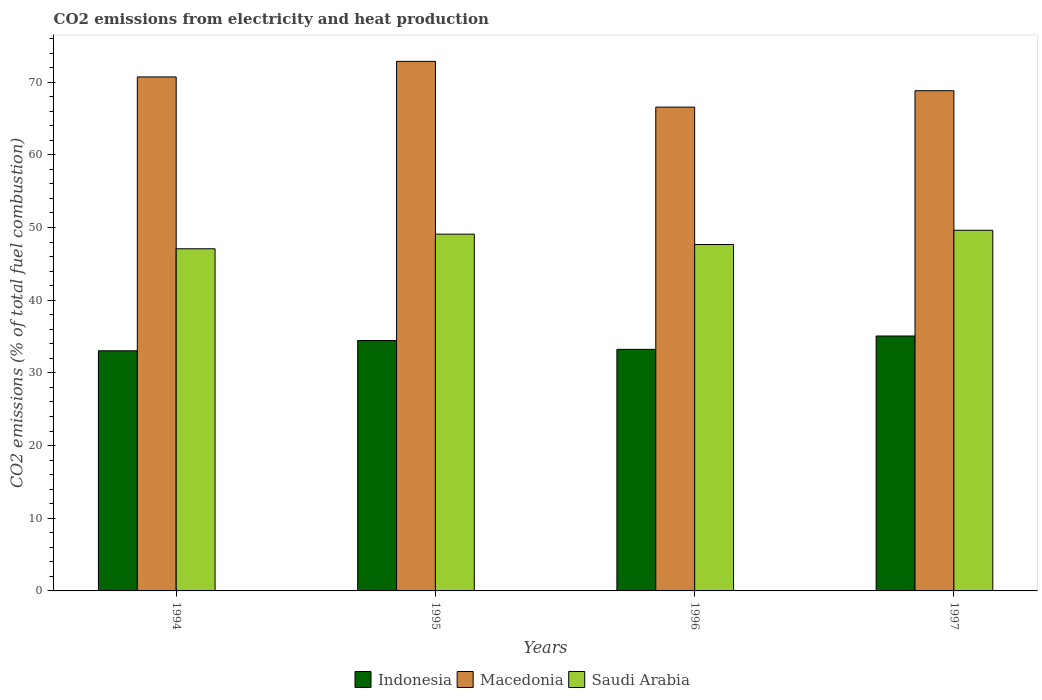How many groups of bars are there?
Provide a short and direct response. 4. Are the number of bars on each tick of the X-axis equal?
Give a very brief answer. Yes. How many bars are there on the 1st tick from the right?
Provide a succinct answer. 3. In how many cases, is the number of bars for a given year not equal to the number of legend labels?
Provide a short and direct response. 0. What is the amount of CO2 emitted in Macedonia in 1996?
Give a very brief answer. 66.56. Across all years, what is the maximum amount of CO2 emitted in Saudi Arabia?
Your response must be concise. 49.62. Across all years, what is the minimum amount of CO2 emitted in Indonesia?
Your answer should be very brief. 33.04. In which year was the amount of CO2 emitted in Indonesia maximum?
Your answer should be compact. 1997. What is the total amount of CO2 emitted in Indonesia in the graph?
Your response must be concise. 135.8. What is the difference between the amount of CO2 emitted in Macedonia in 1995 and that in 1997?
Offer a terse response. 4.04. What is the difference between the amount of CO2 emitted in Indonesia in 1997 and the amount of CO2 emitted in Saudi Arabia in 1995?
Give a very brief answer. -14.01. What is the average amount of CO2 emitted in Saudi Arabia per year?
Provide a short and direct response. 48.36. In the year 1994, what is the difference between the amount of CO2 emitted in Macedonia and amount of CO2 emitted in Saudi Arabia?
Give a very brief answer. 23.64. In how many years, is the amount of CO2 emitted in Indonesia greater than 10 %?
Your answer should be very brief. 4. What is the ratio of the amount of CO2 emitted in Indonesia in 1995 to that in 1996?
Your answer should be compact. 1.04. Is the amount of CO2 emitted in Saudi Arabia in 1994 less than that in 1996?
Offer a terse response. Yes. What is the difference between the highest and the second highest amount of CO2 emitted in Saudi Arabia?
Keep it short and to the point. 0.53. What is the difference between the highest and the lowest amount of CO2 emitted in Macedonia?
Give a very brief answer. 6.3. In how many years, is the amount of CO2 emitted in Macedonia greater than the average amount of CO2 emitted in Macedonia taken over all years?
Your answer should be compact. 2. What does the 3rd bar from the left in 1997 represents?
Keep it short and to the point. Saudi Arabia. What does the 1st bar from the right in 1996 represents?
Give a very brief answer. Saudi Arabia. Are all the bars in the graph horizontal?
Keep it short and to the point. No. Does the graph contain any zero values?
Keep it short and to the point. No. How many legend labels are there?
Your response must be concise. 3. How are the legend labels stacked?
Offer a terse response. Horizontal. What is the title of the graph?
Ensure brevity in your answer.  CO2 emissions from electricity and heat production. Does "Mauritania" appear as one of the legend labels in the graph?
Offer a very short reply. No. What is the label or title of the X-axis?
Give a very brief answer. Years. What is the label or title of the Y-axis?
Make the answer very short. CO2 emissions (% of total fuel combustion). What is the CO2 emissions (% of total fuel combustion) in Indonesia in 1994?
Provide a succinct answer. 33.04. What is the CO2 emissions (% of total fuel combustion) in Macedonia in 1994?
Provide a short and direct response. 70.72. What is the CO2 emissions (% of total fuel combustion) in Saudi Arabia in 1994?
Offer a very short reply. 47.07. What is the CO2 emissions (% of total fuel combustion) of Indonesia in 1995?
Offer a terse response. 34.45. What is the CO2 emissions (% of total fuel combustion) in Macedonia in 1995?
Make the answer very short. 72.86. What is the CO2 emissions (% of total fuel combustion) in Saudi Arabia in 1995?
Offer a very short reply. 49.09. What is the CO2 emissions (% of total fuel combustion) in Indonesia in 1996?
Your response must be concise. 33.24. What is the CO2 emissions (% of total fuel combustion) of Macedonia in 1996?
Offer a very short reply. 66.56. What is the CO2 emissions (% of total fuel combustion) of Saudi Arabia in 1996?
Ensure brevity in your answer.  47.66. What is the CO2 emissions (% of total fuel combustion) of Indonesia in 1997?
Your response must be concise. 35.07. What is the CO2 emissions (% of total fuel combustion) of Macedonia in 1997?
Provide a succinct answer. 68.82. What is the CO2 emissions (% of total fuel combustion) of Saudi Arabia in 1997?
Offer a very short reply. 49.62. Across all years, what is the maximum CO2 emissions (% of total fuel combustion) of Indonesia?
Provide a short and direct response. 35.07. Across all years, what is the maximum CO2 emissions (% of total fuel combustion) in Macedonia?
Offer a very short reply. 72.86. Across all years, what is the maximum CO2 emissions (% of total fuel combustion) of Saudi Arabia?
Give a very brief answer. 49.62. Across all years, what is the minimum CO2 emissions (% of total fuel combustion) of Indonesia?
Your answer should be very brief. 33.04. Across all years, what is the minimum CO2 emissions (% of total fuel combustion) in Macedonia?
Offer a very short reply. 66.56. Across all years, what is the minimum CO2 emissions (% of total fuel combustion) in Saudi Arabia?
Keep it short and to the point. 47.07. What is the total CO2 emissions (% of total fuel combustion) of Indonesia in the graph?
Provide a succinct answer. 135.8. What is the total CO2 emissions (% of total fuel combustion) of Macedonia in the graph?
Provide a succinct answer. 278.96. What is the total CO2 emissions (% of total fuel combustion) of Saudi Arabia in the graph?
Offer a terse response. 193.44. What is the difference between the CO2 emissions (% of total fuel combustion) in Indonesia in 1994 and that in 1995?
Give a very brief answer. -1.41. What is the difference between the CO2 emissions (% of total fuel combustion) in Macedonia in 1994 and that in 1995?
Offer a terse response. -2.14. What is the difference between the CO2 emissions (% of total fuel combustion) in Saudi Arabia in 1994 and that in 1995?
Make the answer very short. -2.01. What is the difference between the CO2 emissions (% of total fuel combustion) in Indonesia in 1994 and that in 1996?
Your answer should be compact. -0.2. What is the difference between the CO2 emissions (% of total fuel combustion) of Macedonia in 1994 and that in 1996?
Ensure brevity in your answer.  4.15. What is the difference between the CO2 emissions (% of total fuel combustion) of Saudi Arabia in 1994 and that in 1996?
Your answer should be very brief. -0.59. What is the difference between the CO2 emissions (% of total fuel combustion) in Indonesia in 1994 and that in 1997?
Your answer should be compact. -2.04. What is the difference between the CO2 emissions (% of total fuel combustion) of Macedonia in 1994 and that in 1997?
Ensure brevity in your answer.  1.89. What is the difference between the CO2 emissions (% of total fuel combustion) in Saudi Arabia in 1994 and that in 1997?
Provide a short and direct response. -2.54. What is the difference between the CO2 emissions (% of total fuel combustion) in Indonesia in 1995 and that in 1996?
Make the answer very short. 1.22. What is the difference between the CO2 emissions (% of total fuel combustion) in Macedonia in 1995 and that in 1996?
Provide a short and direct response. 6.3. What is the difference between the CO2 emissions (% of total fuel combustion) in Saudi Arabia in 1995 and that in 1996?
Provide a succinct answer. 1.42. What is the difference between the CO2 emissions (% of total fuel combustion) in Indonesia in 1995 and that in 1997?
Make the answer very short. -0.62. What is the difference between the CO2 emissions (% of total fuel combustion) in Macedonia in 1995 and that in 1997?
Provide a succinct answer. 4.04. What is the difference between the CO2 emissions (% of total fuel combustion) of Saudi Arabia in 1995 and that in 1997?
Provide a short and direct response. -0.53. What is the difference between the CO2 emissions (% of total fuel combustion) in Indonesia in 1996 and that in 1997?
Ensure brevity in your answer.  -1.84. What is the difference between the CO2 emissions (% of total fuel combustion) in Macedonia in 1996 and that in 1997?
Your response must be concise. -2.26. What is the difference between the CO2 emissions (% of total fuel combustion) of Saudi Arabia in 1996 and that in 1997?
Make the answer very short. -1.96. What is the difference between the CO2 emissions (% of total fuel combustion) of Indonesia in 1994 and the CO2 emissions (% of total fuel combustion) of Macedonia in 1995?
Offer a terse response. -39.82. What is the difference between the CO2 emissions (% of total fuel combustion) in Indonesia in 1994 and the CO2 emissions (% of total fuel combustion) in Saudi Arabia in 1995?
Your answer should be compact. -16.05. What is the difference between the CO2 emissions (% of total fuel combustion) in Macedonia in 1994 and the CO2 emissions (% of total fuel combustion) in Saudi Arabia in 1995?
Provide a succinct answer. 21.63. What is the difference between the CO2 emissions (% of total fuel combustion) in Indonesia in 1994 and the CO2 emissions (% of total fuel combustion) in Macedonia in 1996?
Provide a succinct answer. -33.53. What is the difference between the CO2 emissions (% of total fuel combustion) of Indonesia in 1994 and the CO2 emissions (% of total fuel combustion) of Saudi Arabia in 1996?
Give a very brief answer. -14.62. What is the difference between the CO2 emissions (% of total fuel combustion) of Macedonia in 1994 and the CO2 emissions (% of total fuel combustion) of Saudi Arabia in 1996?
Your answer should be compact. 23.05. What is the difference between the CO2 emissions (% of total fuel combustion) of Indonesia in 1994 and the CO2 emissions (% of total fuel combustion) of Macedonia in 1997?
Make the answer very short. -35.78. What is the difference between the CO2 emissions (% of total fuel combustion) in Indonesia in 1994 and the CO2 emissions (% of total fuel combustion) in Saudi Arabia in 1997?
Provide a short and direct response. -16.58. What is the difference between the CO2 emissions (% of total fuel combustion) in Macedonia in 1994 and the CO2 emissions (% of total fuel combustion) in Saudi Arabia in 1997?
Your response must be concise. 21.1. What is the difference between the CO2 emissions (% of total fuel combustion) of Indonesia in 1995 and the CO2 emissions (% of total fuel combustion) of Macedonia in 1996?
Provide a succinct answer. -32.11. What is the difference between the CO2 emissions (% of total fuel combustion) in Indonesia in 1995 and the CO2 emissions (% of total fuel combustion) in Saudi Arabia in 1996?
Your answer should be very brief. -13.21. What is the difference between the CO2 emissions (% of total fuel combustion) in Macedonia in 1995 and the CO2 emissions (% of total fuel combustion) in Saudi Arabia in 1996?
Give a very brief answer. 25.2. What is the difference between the CO2 emissions (% of total fuel combustion) of Indonesia in 1995 and the CO2 emissions (% of total fuel combustion) of Macedonia in 1997?
Your response must be concise. -34.37. What is the difference between the CO2 emissions (% of total fuel combustion) in Indonesia in 1995 and the CO2 emissions (% of total fuel combustion) in Saudi Arabia in 1997?
Your answer should be compact. -15.17. What is the difference between the CO2 emissions (% of total fuel combustion) of Macedonia in 1995 and the CO2 emissions (% of total fuel combustion) of Saudi Arabia in 1997?
Your answer should be compact. 23.24. What is the difference between the CO2 emissions (% of total fuel combustion) in Indonesia in 1996 and the CO2 emissions (% of total fuel combustion) in Macedonia in 1997?
Keep it short and to the point. -35.59. What is the difference between the CO2 emissions (% of total fuel combustion) in Indonesia in 1996 and the CO2 emissions (% of total fuel combustion) in Saudi Arabia in 1997?
Your response must be concise. -16.38. What is the difference between the CO2 emissions (% of total fuel combustion) in Macedonia in 1996 and the CO2 emissions (% of total fuel combustion) in Saudi Arabia in 1997?
Make the answer very short. 16.94. What is the average CO2 emissions (% of total fuel combustion) of Indonesia per year?
Offer a terse response. 33.95. What is the average CO2 emissions (% of total fuel combustion) in Macedonia per year?
Offer a terse response. 69.74. What is the average CO2 emissions (% of total fuel combustion) in Saudi Arabia per year?
Provide a short and direct response. 48.36. In the year 1994, what is the difference between the CO2 emissions (% of total fuel combustion) of Indonesia and CO2 emissions (% of total fuel combustion) of Macedonia?
Your response must be concise. -37.68. In the year 1994, what is the difference between the CO2 emissions (% of total fuel combustion) of Indonesia and CO2 emissions (% of total fuel combustion) of Saudi Arabia?
Provide a succinct answer. -14.04. In the year 1994, what is the difference between the CO2 emissions (% of total fuel combustion) in Macedonia and CO2 emissions (% of total fuel combustion) in Saudi Arabia?
Offer a terse response. 23.64. In the year 1995, what is the difference between the CO2 emissions (% of total fuel combustion) of Indonesia and CO2 emissions (% of total fuel combustion) of Macedonia?
Keep it short and to the point. -38.41. In the year 1995, what is the difference between the CO2 emissions (% of total fuel combustion) in Indonesia and CO2 emissions (% of total fuel combustion) in Saudi Arabia?
Give a very brief answer. -14.63. In the year 1995, what is the difference between the CO2 emissions (% of total fuel combustion) of Macedonia and CO2 emissions (% of total fuel combustion) of Saudi Arabia?
Keep it short and to the point. 23.77. In the year 1996, what is the difference between the CO2 emissions (% of total fuel combustion) of Indonesia and CO2 emissions (% of total fuel combustion) of Macedonia?
Your answer should be compact. -33.33. In the year 1996, what is the difference between the CO2 emissions (% of total fuel combustion) of Indonesia and CO2 emissions (% of total fuel combustion) of Saudi Arabia?
Your answer should be compact. -14.43. In the year 1996, what is the difference between the CO2 emissions (% of total fuel combustion) in Macedonia and CO2 emissions (% of total fuel combustion) in Saudi Arabia?
Ensure brevity in your answer.  18.9. In the year 1997, what is the difference between the CO2 emissions (% of total fuel combustion) of Indonesia and CO2 emissions (% of total fuel combustion) of Macedonia?
Your response must be concise. -33.75. In the year 1997, what is the difference between the CO2 emissions (% of total fuel combustion) of Indonesia and CO2 emissions (% of total fuel combustion) of Saudi Arabia?
Make the answer very short. -14.54. In the year 1997, what is the difference between the CO2 emissions (% of total fuel combustion) in Macedonia and CO2 emissions (% of total fuel combustion) in Saudi Arabia?
Make the answer very short. 19.2. What is the ratio of the CO2 emissions (% of total fuel combustion) in Indonesia in 1994 to that in 1995?
Provide a succinct answer. 0.96. What is the ratio of the CO2 emissions (% of total fuel combustion) of Macedonia in 1994 to that in 1995?
Ensure brevity in your answer.  0.97. What is the ratio of the CO2 emissions (% of total fuel combustion) in Saudi Arabia in 1994 to that in 1995?
Provide a succinct answer. 0.96. What is the ratio of the CO2 emissions (% of total fuel combustion) of Macedonia in 1994 to that in 1996?
Give a very brief answer. 1.06. What is the ratio of the CO2 emissions (% of total fuel combustion) of Saudi Arabia in 1994 to that in 1996?
Make the answer very short. 0.99. What is the ratio of the CO2 emissions (% of total fuel combustion) of Indonesia in 1994 to that in 1997?
Your answer should be very brief. 0.94. What is the ratio of the CO2 emissions (% of total fuel combustion) in Macedonia in 1994 to that in 1997?
Your answer should be compact. 1.03. What is the ratio of the CO2 emissions (% of total fuel combustion) in Saudi Arabia in 1994 to that in 1997?
Provide a succinct answer. 0.95. What is the ratio of the CO2 emissions (% of total fuel combustion) in Indonesia in 1995 to that in 1996?
Your answer should be very brief. 1.04. What is the ratio of the CO2 emissions (% of total fuel combustion) in Macedonia in 1995 to that in 1996?
Offer a terse response. 1.09. What is the ratio of the CO2 emissions (% of total fuel combustion) of Saudi Arabia in 1995 to that in 1996?
Your response must be concise. 1.03. What is the ratio of the CO2 emissions (% of total fuel combustion) in Indonesia in 1995 to that in 1997?
Your response must be concise. 0.98. What is the ratio of the CO2 emissions (% of total fuel combustion) of Macedonia in 1995 to that in 1997?
Give a very brief answer. 1.06. What is the ratio of the CO2 emissions (% of total fuel combustion) of Saudi Arabia in 1995 to that in 1997?
Give a very brief answer. 0.99. What is the ratio of the CO2 emissions (% of total fuel combustion) in Indonesia in 1996 to that in 1997?
Make the answer very short. 0.95. What is the ratio of the CO2 emissions (% of total fuel combustion) of Macedonia in 1996 to that in 1997?
Keep it short and to the point. 0.97. What is the ratio of the CO2 emissions (% of total fuel combustion) in Saudi Arabia in 1996 to that in 1997?
Your response must be concise. 0.96. What is the difference between the highest and the second highest CO2 emissions (% of total fuel combustion) in Indonesia?
Keep it short and to the point. 0.62. What is the difference between the highest and the second highest CO2 emissions (% of total fuel combustion) of Macedonia?
Your answer should be compact. 2.14. What is the difference between the highest and the second highest CO2 emissions (% of total fuel combustion) in Saudi Arabia?
Ensure brevity in your answer.  0.53. What is the difference between the highest and the lowest CO2 emissions (% of total fuel combustion) of Indonesia?
Your answer should be very brief. 2.04. What is the difference between the highest and the lowest CO2 emissions (% of total fuel combustion) of Macedonia?
Your response must be concise. 6.3. What is the difference between the highest and the lowest CO2 emissions (% of total fuel combustion) in Saudi Arabia?
Give a very brief answer. 2.54. 